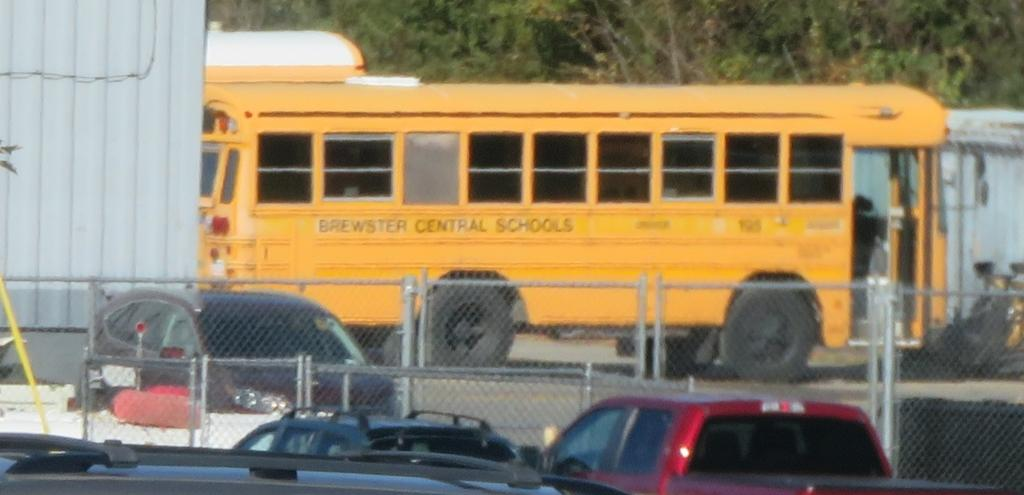<image>
Give a short and clear explanation of the subsequent image. a yellow school bus reading Brewster Central Schools 